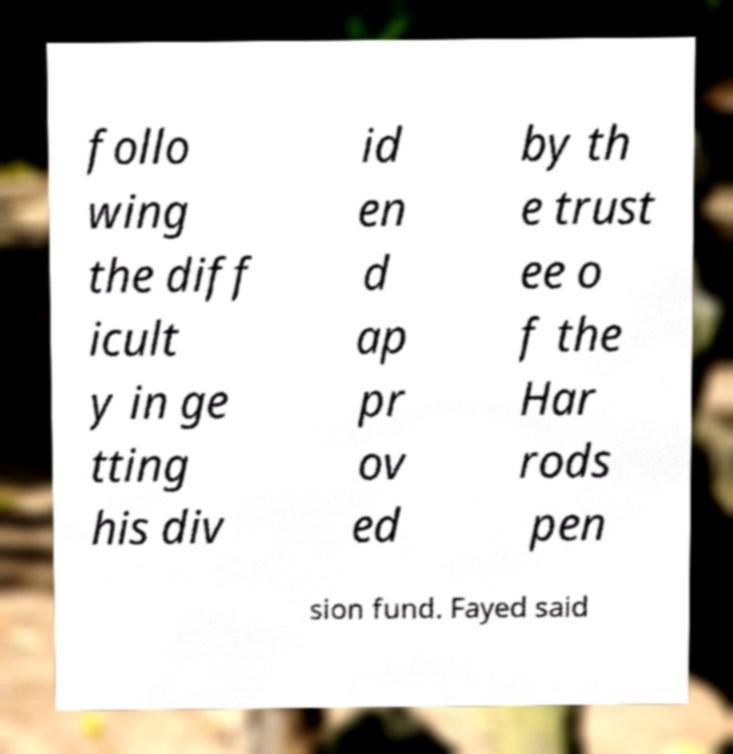There's text embedded in this image that I need extracted. Can you transcribe it verbatim? follo wing the diff icult y in ge tting his div id en d ap pr ov ed by th e trust ee o f the Har rods pen sion fund. Fayed said 